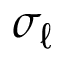<formula> <loc_0><loc_0><loc_500><loc_500>\sigma _ { \ell }</formula> 